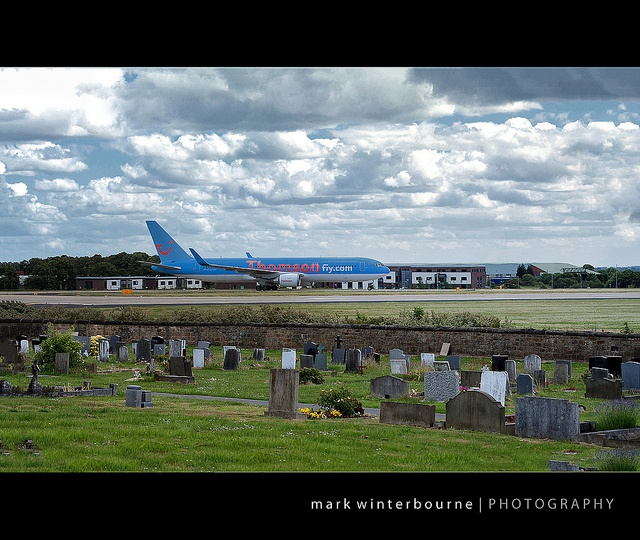Describe the objects in this image and their specific colors. I can see a airplane in black, blue, and gray tones in this image. 